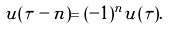<formula> <loc_0><loc_0><loc_500><loc_500>u ( \tau - n ) = ( - 1 ) ^ { n } u ( \tau ) .</formula> 